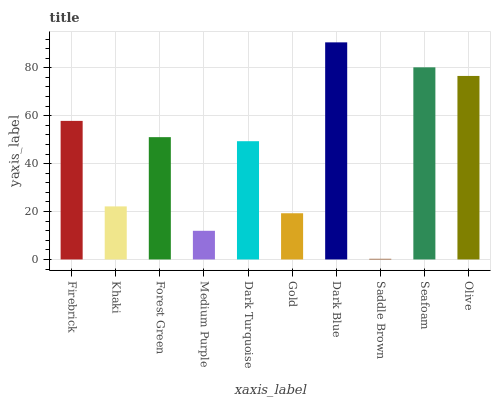Is Khaki the minimum?
Answer yes or no. No. Is Khaki the maximum?
Answer yes or no. No. Is Firebrick greater than Khaki?
Answer yes or no. Yes. Is Khaki less than Firebrick?
Answer yes or no. Yes. Is Khaki greater than Firebrick?
Answer yes or no. No. Is Firebrick less than Khaki?
Answer yes or no. No. Is Forest Green the high median?
Answer yes or no. Yes. Is Dark Turquoise the low median?
Answer yes or no. Yes. Is Dark Blue the high median?
Answer yes or no. No. Is Khaki the low median?
Answer yes or no. No. 